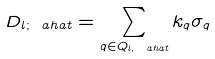Convert formula to latex. <formula><loc_0><loc_0><loc_500><loc_500>D _ { l ; \ a h a t } = \sum _ { q \in Q _ { l , \ a h a t } } k _ { q } \sigma _ { q }</formula> 